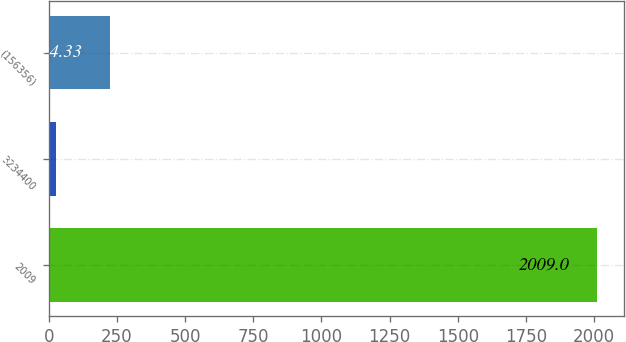<chart> <loc_0><loc_0><loc_500><loc_500><bar_chart><fcel>2009<fcel>3234400<fcel>(156356)<nl><fcel>2009<fcel>26.03<fcel>224.33<nl></chart> 